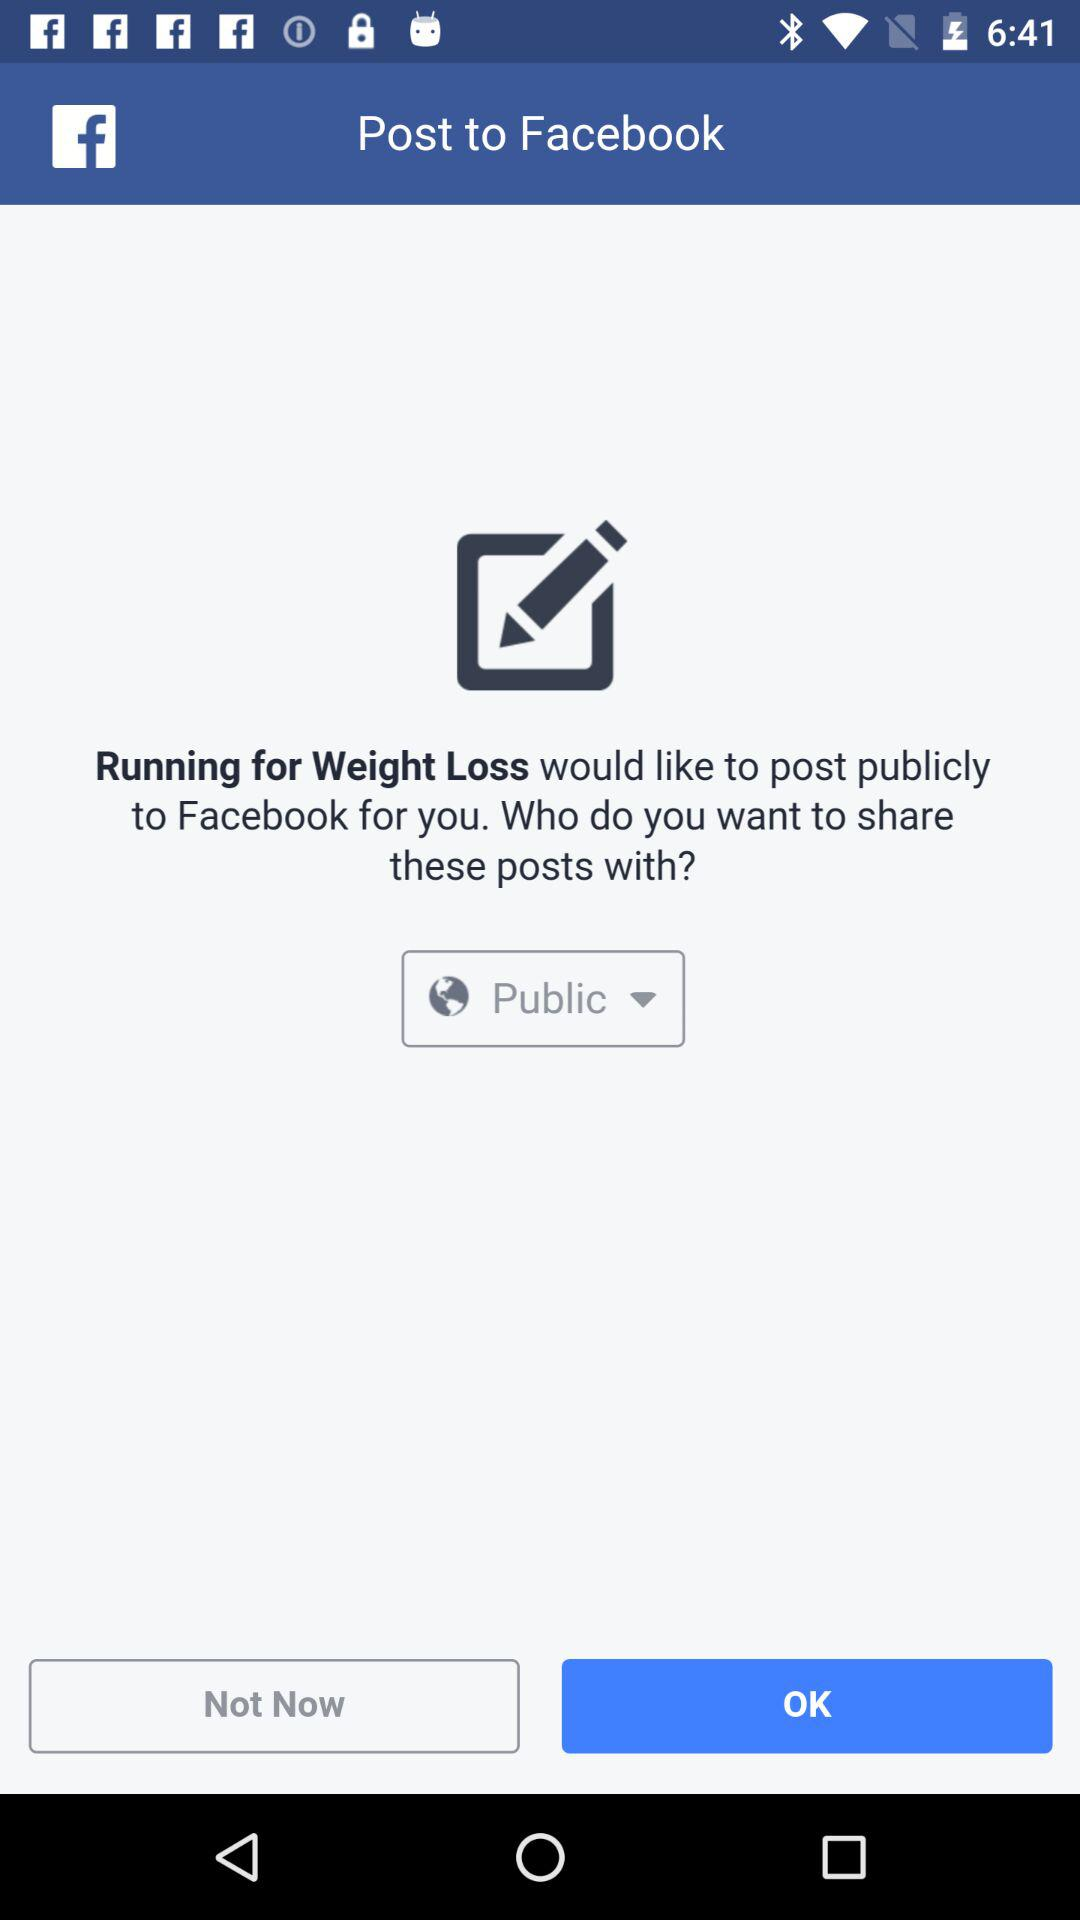Which application will post publicly on "Facebook"? The application is "Running for Weight Loss". 